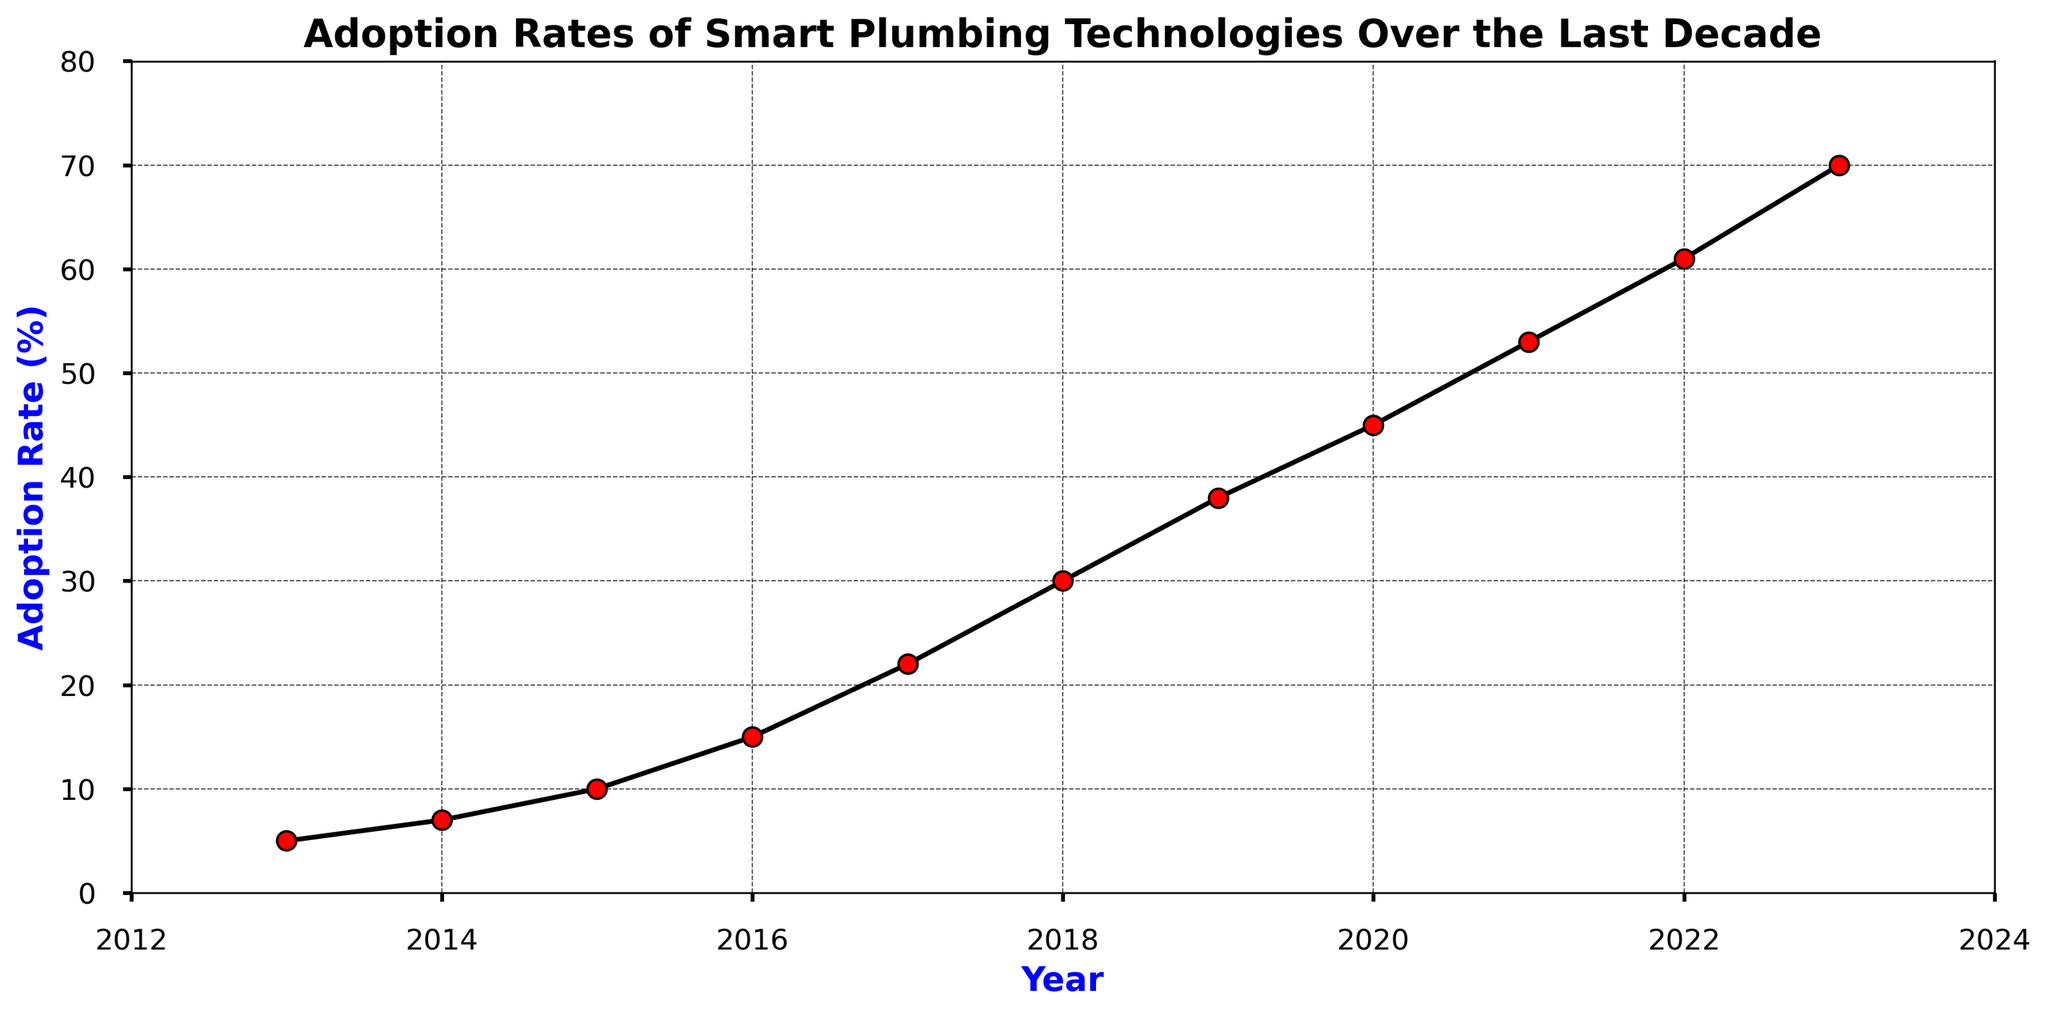Which year saw the highest adoption rate of smart plumbing technologies? The highest point on the line chart indicates the highest adoption rate. In this case, the adoption rate peaks at 70% in 2023.
Answer: 2023 How much did the adoption rate increase between 2013 and 2023? Subtract the adoption rate in 2013 (5%) from the adoption rate in 2023 (70%). The increase is 70% - 5% = 65%.
Answer: 65% Is the adoption rate increase between 2018 and 2019 greater than between 2015 and 2016? Compare the differences: from 2018 to 2019, the rate increased by 38% - 30% = 8%. From 2015 to 2016, it increased by 15% - 10% = 5%. Since 8% is greater than 5%, the increase between 2018 and 2019 is indeed greater.
Answer: Yes Which two consecutive years show the highest growth in adoption rates? Calculate the differences between consecutive years: 2018-2019 (8%), 2017-2018 (8%), 2022-2023 (9%). The highest growth is between 2022 and 2023 with 9%.
Answer: 2022-2023 What is the average adoption rate from 2015 to 2020? Add the rates from 2015 to 2020 (10% + 15% + 22% + 30% + 38% + 45%) and divide by the number of years (6): (10 + 15 + 22 + 30 + 38 + 45) / 6 = 26.67%.
Answer: 26.67% Did the adoption rate increase every year? Check if the adoption rate increased each year by observing that each point on the line chart is higher than the previous one. Since the rate increases each year, the answer is yes.
Answer: Yes How much slower was the adoption rate in 2015 compared to 2020? Subtract the adoption rate in 2015 (10%) from the adoption rate in 2020 (45%) to find the difference: 45% - 10% = 35%.
Answer: 35% By what percentage did the adoption rate grow from 2017 to 2020? Calculate the difference between 2020 and 2017 rates (45% - 22%) and then divide by 2017 rate, multiplying by 100: ((45 - 22) / 22) * 100 = 104.55%.
Answer: 104.55% How many years did it take for the adoption rate to double from its initial rate in 2013? The initial rate in 2013 is 5%; to double means reaching 10%. This occurs in 2015, so it took 2015 - 2013 = 2 years.
Answer: 2 Is the adoption rate increase between 2013 and 2016 greater than that between 2019 and 2022? Between 2013 and 2016, the increase is 15% - 5% = 10%. Between 2019 and 2022, the increase is 61% - 38% = 23%. Since 23% is greater than 10%, the increase between 2019 and 2022 is greater.
Answer: No 